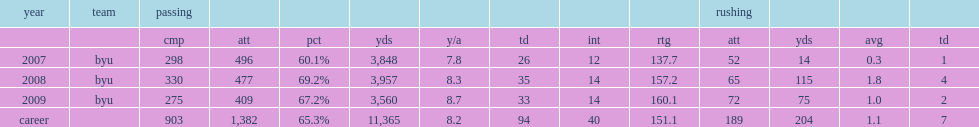How many passing yards did max hall have in 2007. 3848.0. 